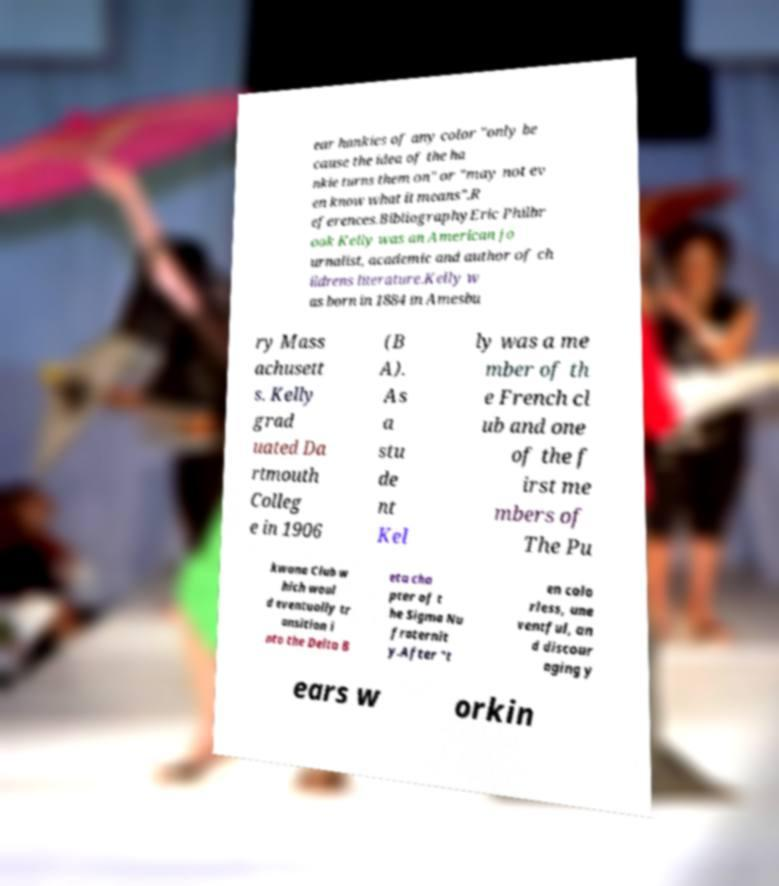I need the written content from this picture converted into text. Can you do that? ear hankies of any color "only be cause the idea of the ha nkie turns them on" or "may not ev en know what it means".R eferences.BibliographyEric Philbr ook Kelly was an American jo urnalist, academic and author of ch ildrens literature.Kelly w as born in 1884 in Amesbu ry Mass achusett s. Kelly grad uated Da rtmouth Colleg e in 1906 (B A). As a stu de nt Kel ly was a me mber of th e French cl ub and one of the f irst me mbers of The Pu kwana Club w hich woul d eventually tr ansition i nto the Delta B eta cha pter of t he Sigma Nu fraternit y.After "t en colo rless, une ventful, an d discour aging y ears w orkin 